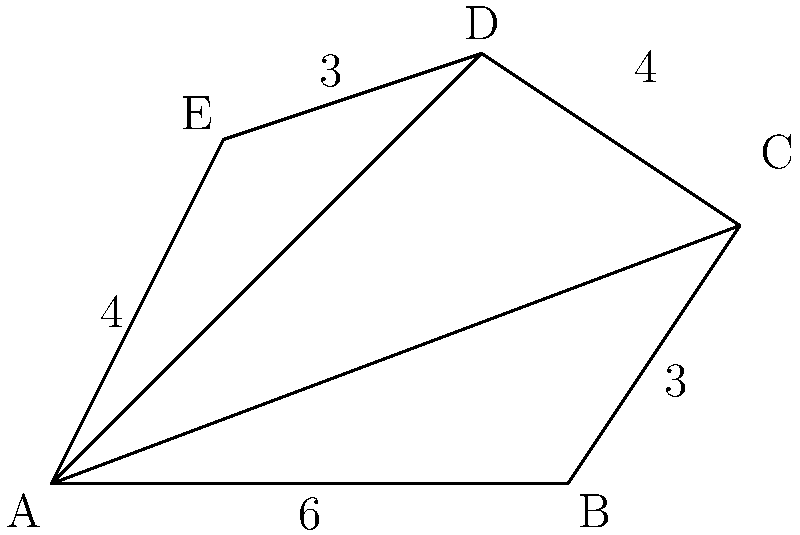As a Change Creator team member working on a sustainable urban development project, you need to calculate the area of an irregular plot of land. The plot is represented by the polygon ABCDE in the figure above. Given the coordinates of the vertices and using the triangulation method, calculate the total area of the polygon. To find the area of the irregular polygon ABCDE, we'll use the triangulation method:

1. Divide the polygon into three triangles: ABC, ACD, and ADE.

2. Calculate the area of each triangle using the formula:
   Area = $\frac{1}{2}|x_1(y_2 - y_3) + x_2(y_3 - y_1) + x_3(y_1 - y_2)|$

3. For triangle ABC:
   $A_{ABC} = \frac{1}{2}|0(0 - 3) + 6(3 - 0) + 8(0 - 0)| = 9$ square units

4. For triangle ACD:
   $A_{ACD} = \frac{1}{2}|0(3 - 5) + 8(5 - 0) + 5(0 - 3)| = 12.5$ square units

5. For triangle ADE:
   $A_{ADE} = \frac{1}{2}|0(5 - 4) + 5(4 - 0) + 2(0 - 5)| = 7.5$ square units

6. Sum up the areas of all triangles:
   Total Area = $A_{ABC} + A_{ACD} + A_{ADE}$
               = $9 + 12.5 + 7.5$
               = $29$ square units
Answer: 29 square units 